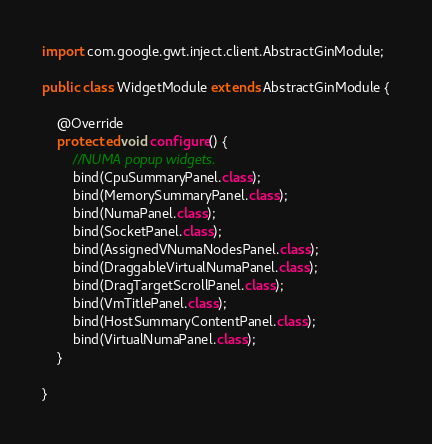Convert code to text. <code><loc_0><loc_0><loc_500><loc_500><_Java_>
import com.google.gwt.inject.client.AbstractGinModule;

public class WidgetModule extends AbstractGinModule {

    @Override
    protected void configure() {
        //NUMA popup widgets.
        bind(CpuSummaryPanel.class);
        bind(MemorySummaryPanel.class);
        bind(NumaPanel.class);
        bind(SocketPanel.class);
        bind(AssignedVNumaNodesPanel.class);
        bind(DraggableVirtualNumaPanel.class);
        bind(DragTargetScrollPanel.class);
        bind(VmTitlePanel.class);
        bind(HostSummaryContentPanel.class);
        bind(VirtualNumaPanel.class);
    }

}
</code> 